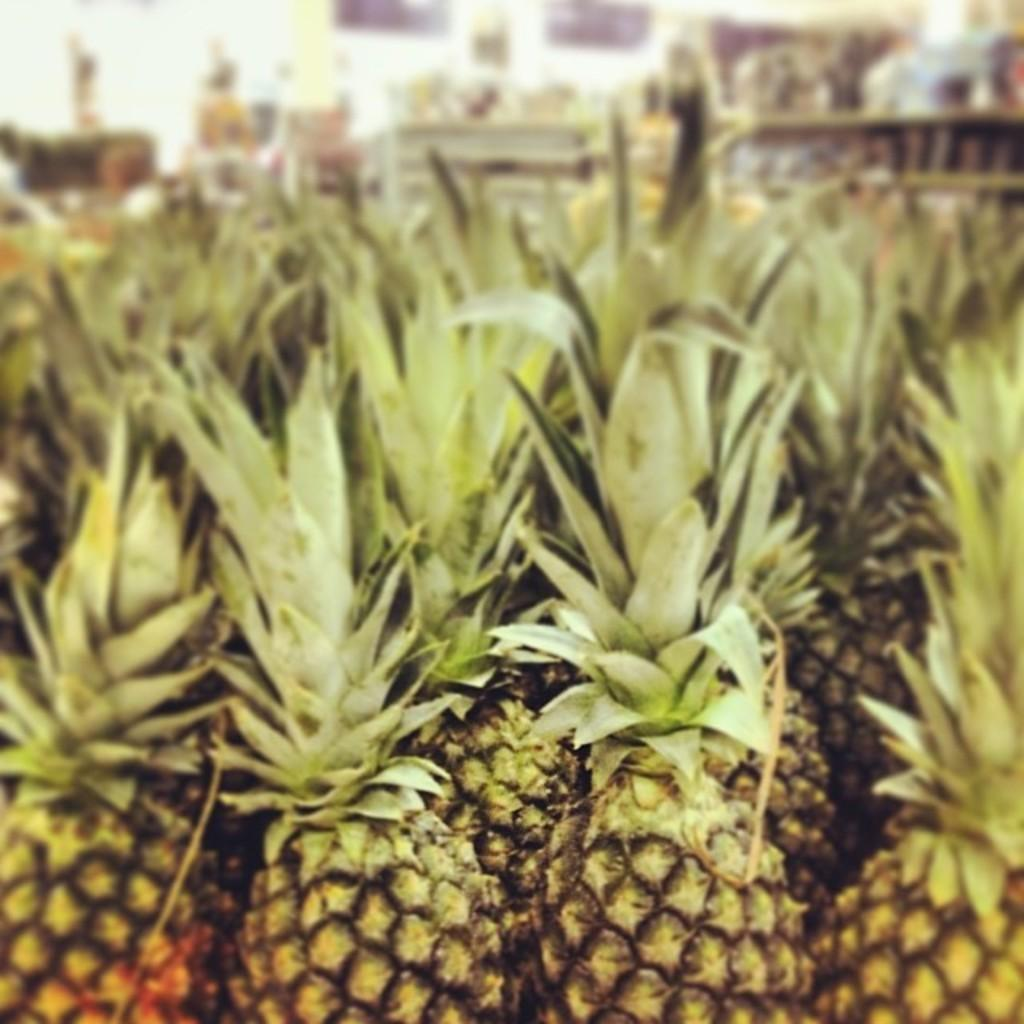What type of fruit is present in the image? There are pineapples in the image. Can you describe the colors of the pineapples? The pineapples have yellow, black, and green colors. How would you describe the background of the image? The background of the image is blurry. How many hens are sitting on the pineapples in the image? There are no hens present in the image; it only features pineapples. What type of winter clothing is visible on the pineapples in the image? There is no winter clothing, such as mittens, present on the pineapples in the image. 